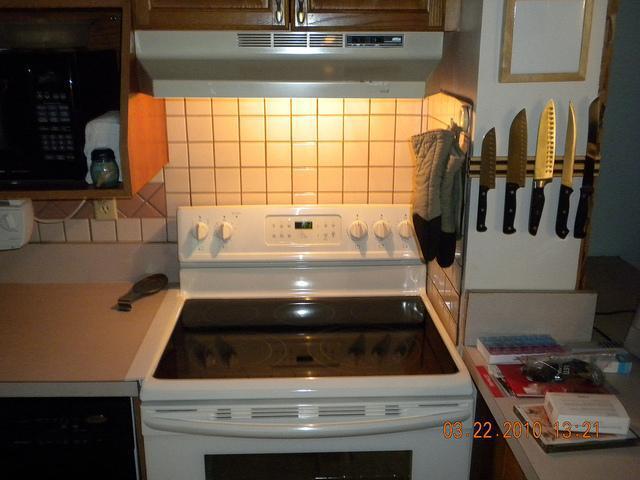How many knives are there?
Give a very brief answer. 2. 